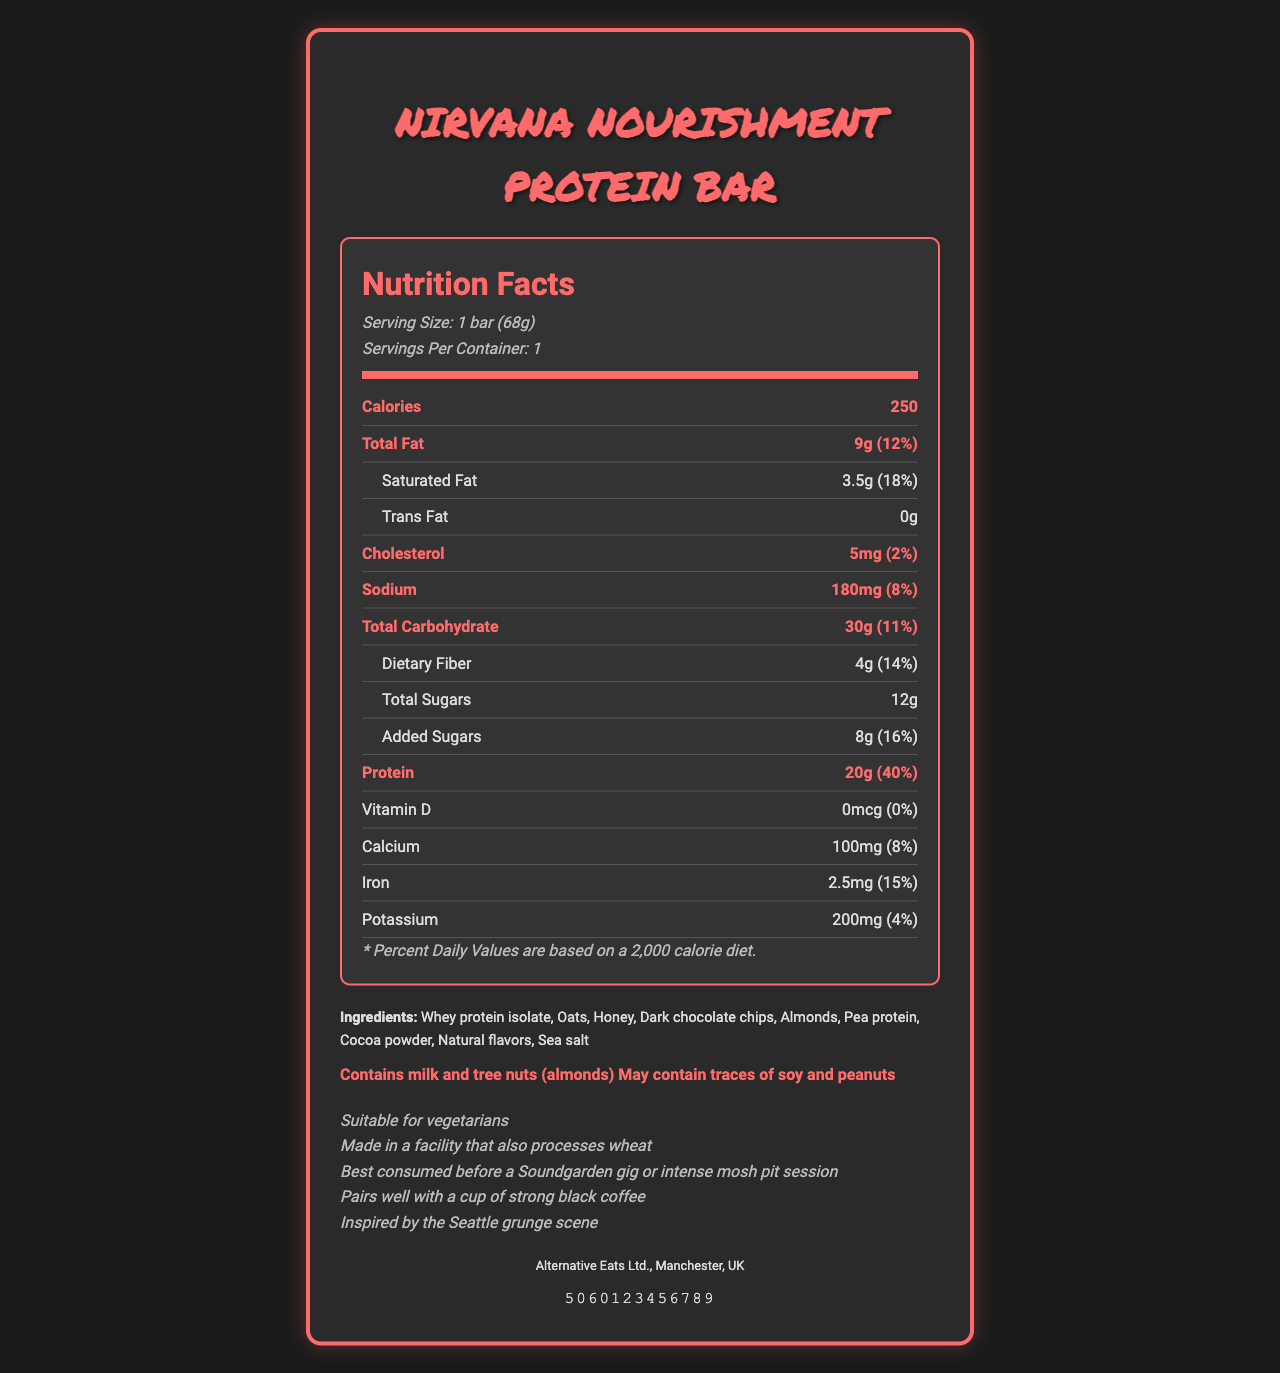What is the serving size of the Nirvana Nourishment Protein Bar? The serving size is directly listed on the document as "1 bar (68g)".
Answer: 1 bar (68g) How many calories does one Nirvana Nourishment Protein Bar contain? The calorie content is shown as 250 in the nutrition facts.
Answer: 250 What percent of the daily value of protein does one bar provide? The protein content is listed as 20g, which is 40% of the daily value.
Answer: 40% What are the three main ingredients in the Nirvana Nourishment Protein Bar? The ingredients are listed in order of predominance, and the first three are Whey protein isolate, Oats, and Honey.
Answer: Whey protein isolate, Oats, Honey What company manufactures the Nirvana Nourishment Protein Bar? The manufacturer information is provided at the bottom of the document.
Answer: Alternative Eats Ltd., Manchester, UK Which vitamin is not present in the Nirvana Nourishment Protein Bar? A. Vitamin D B. Calcium C. Iron D. Potassium The document shows 0mcg (0% daily value) for Vitamin D.
Answer: A. Vitamin D How many grams of total fat does one Nirvana Nourishment Protein Bar contain? The total fat content is listed as 9g.
Answer: 9g What is the recommended audience for the Nirvana Nourishment Protein Bar based on the additional information provided? The additional information suggests it is best consumed before a Soundgarden gig or intense mosh pit session.
Answer: Before a Soundgarden gig or intense mosh pit session Does the Nirvana Nourishment Protein Bar contain any allergens? The document states that it contains milk and tree nuts (almonds) and may contain traces of soy and peanuts.
Answer: Yes What is the bar code number for the Nirvana Nourishment Protein Bar? The bar code is displayed directly at the bottom of the document as 5060123456789.
Answer: 5060123456789 Is the Nirvana Nourishment Protein Bar suitable for vegetarians? The additional information states, "Suitable for vegetarians".
Answer: Yes Summarize the main idea of this nutrition facts document. The document covers all essential information for the Nirvana Nourishment Protein Bar, from nutritional content to specific target audience hints and allergen warnings. It also emphasizes its grunge theme.
Answer: The document provides detailed nutrition information for the Nirvana Nourishment Protein Bar, including serving size, calories, macronutrients, and micronutrients. It also lists ingredients, allergens, additional product information, manufacturer details, and the bar code. The bar is designed with a grunge theme inspired by the Seattle grunge scene. Can individuals with a gluten allergy consume this protein bar safely? The document mentions that the bar is made in a facility that processes wheat, but it doesn't specify whether the bar itself contains gluten.
Answer: Not enough information What is the total carbohydrate content and its daily value percentage in one bar? The total carbohydrate is stated as 30g, which is 11% of the daily value.
Answer: 30g, 11% Which of these statements is true about the Nirvana Nourishment Protein Bar? A. It contains caffeine. B. It is vegan. C. It has 20g of protein. D. It contains no allergens. The document states that the bar contains 20g of protein. The other options are incorrect based on the information provided.
Answer: C. It has 20g of protein. 